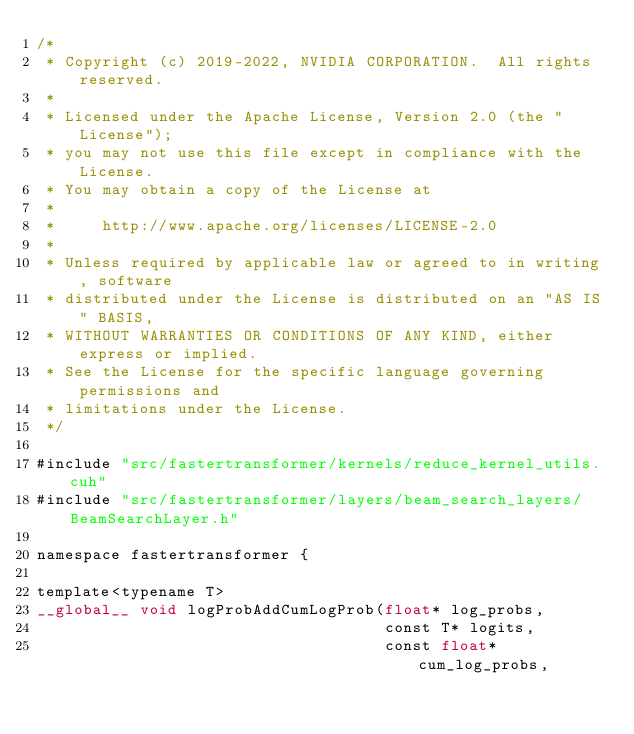<code> <loc_0><loc_0><loc_500><loc_500><_Cuda_>/*
 * Copyright (c) 2019-2022, NVIDIA CORPORATION.  All rights reserved.
 *
 * Licensed under the Apache License, Version 2.0 (the "License");
 * you may not use this file except in compliance with the License.
 * You may obtain a copy of the License at
 *
 *     http://www.apache.org/licenses/LICENSE-2.0
 *
 * Unless required by applicable law or agreed to in writing, software
 * distributed under the License is distributed on an "AS IS" BASIS,
 * WITHOUT WARRANTIES OR CONDITIONS OF ANY KIND, either express or implied.
 * See the License for the specific language governing permissions and
 * limitations under the License.
 */

#include "src/fastertransformer/kernels/reduce_kernel_utils.cuh"
#include "src/fastertransformer/layers/beam_search_layers/BeamSearchLayer.h"

namespace fastertransformer {

template<typename T>
__global__ void logProbAddCumLogProb(float* log_probs,
                                     const T* logits,
                                     const float* cum_log_probs,</code> 